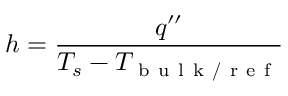<formula> <loc_0><loc_0><loc_500><loc_500>h = \frac { q ^ { \prime \prime } } { T _ { s } - T _ { b u l k / r e f } }</formula> 